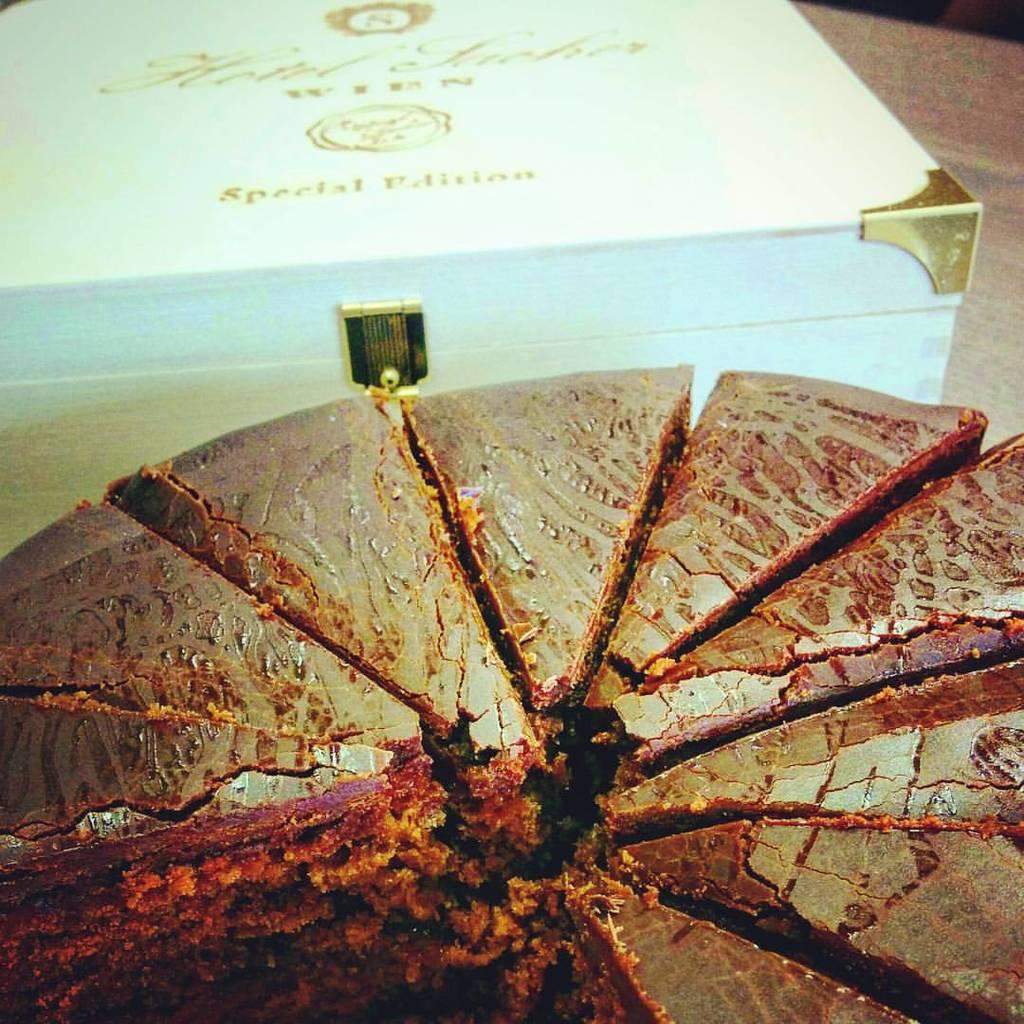What is the main subject of the image? There is a cake in the image. How is the cake presented? The cake is cut into pieces. Where is the cake located? The cake is placed on a table. What other object is present in the image? There is a white color box in the image. How is the white color box positioned in relation to the cake? The white color box is beside the cake. What type of wood can be seen in the image? There is no wood present in the image. What is the chance of winning a prize in the image? There is no indication of a prize or chance in the image. 